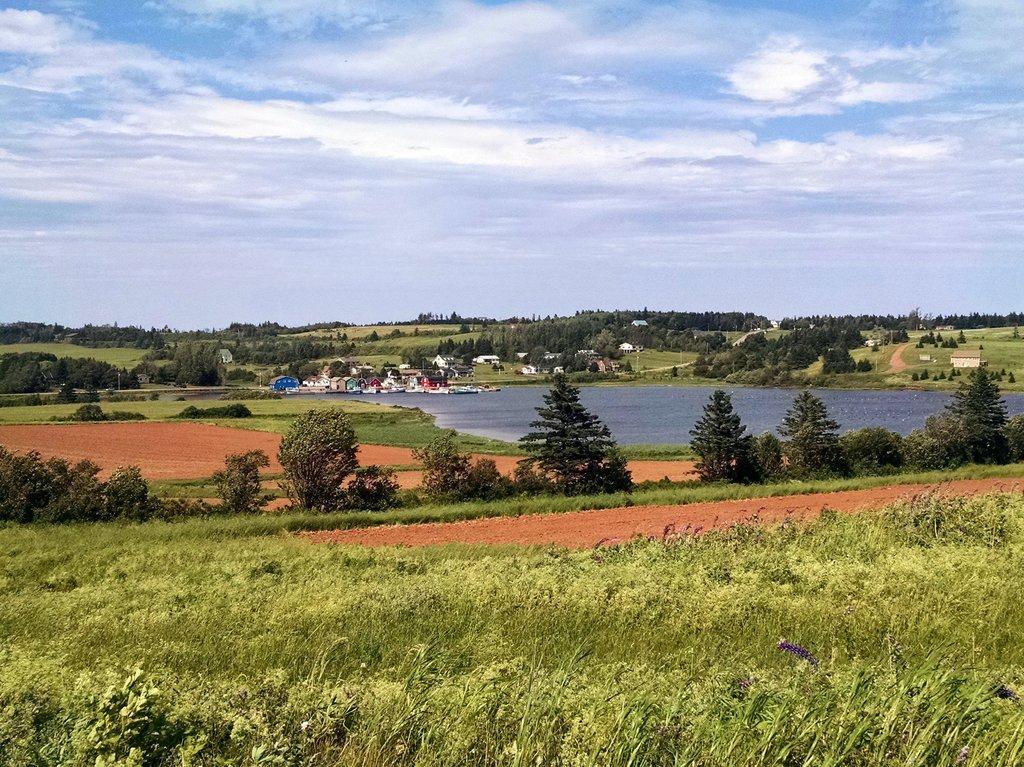In one or two sentences, can you explain what this image depicts? In this picture we can see few plants and trees, in the background we can find water and few houses. 